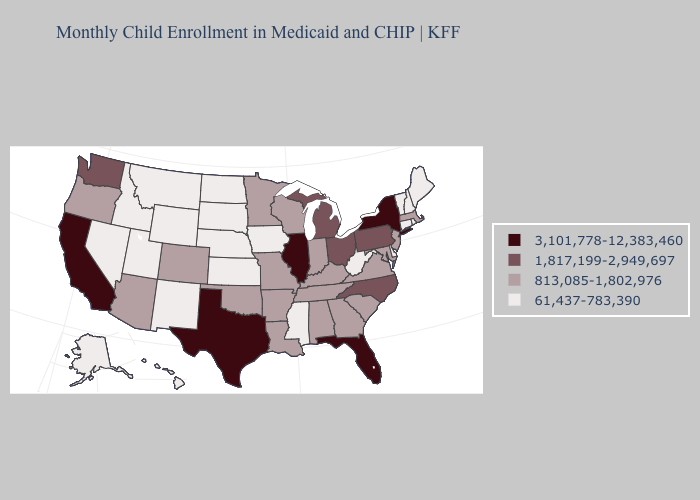Name the states that have a value in the range 813,085-1,802,976?
Be succinct. Alabama, Arizona, Arkansas, Colorado, Georgia, Indiana, Kentucky, Louisiana, Maryland, Massachusetts, Minnesota, Missouri, New Jersey, Oklahoma, Oregon, South Carolina, Tennessee, Virginia, Wisconsin. Does Illinois have the highest value in the USA?
Short answer required. Yes. Does Ohio have the same value as Wisconsin?
Answer briefly. No. What is the lowest value in the West?
Answer briefly. 61,437-783,390. What is the lowest value in the USA?
Quick response, please. 61,437-783,390. What is the lowest value in the West?
Give a very brief answer. 61,437-783,390. Does Connecticut have the same value as Minnesota?
Concise answer only. No. Which states have the lowest value in the Northeast?
Keep it brief. Connecticut, Maine, New Hampshire, Rhode Island, Vermont. Does the map have missing data?
Short answer required. No. Does Pennsylvania have a lower value than Ohio?
Give a very brief answer. No. Does Montana have a lower value than Nebraska?
Write a very short answer. No. Which states hav the highest value in the South?
Give a very brief answer. Florida, Texas. Does Wyoming have the highest value in the West?
Keep it brief. No. Does California have the lowest value in the West?
Give a very brief answer. No. What is the lowest value in states that border South Carolina?
Concise answer only. 813,085-1,802,976. 